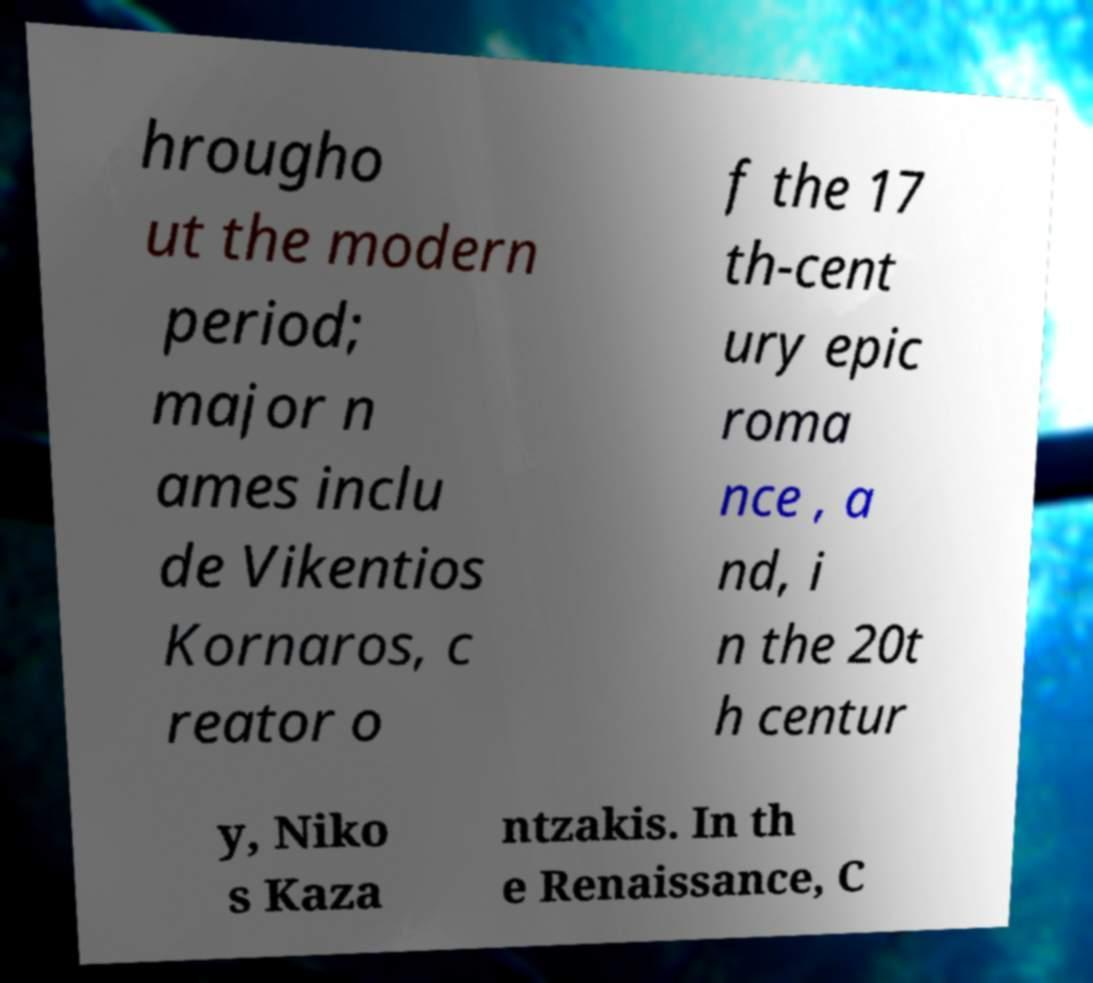Can you accurately transcribe the text from the provided image for me? hrougho ut the modern period; major n ames inclu de Vikentios Kornaros, c reator o f the 17 th-cent ury epic roma nce , a nd, i n the 20t h centur y, Niko s Kaza ntzakis. In th e Renaissance, C 